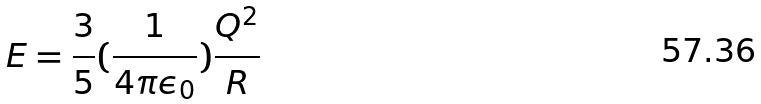Convert formula to latex. <formula><loc_0><loc_0><loc_500><loc_500>E = \frac { 3 } { 5 } ( \frac { 1 } { 4 \pi \epsilon _ { 0 } } ) \frac { Q ^ { 2 } } { R }</formula> 